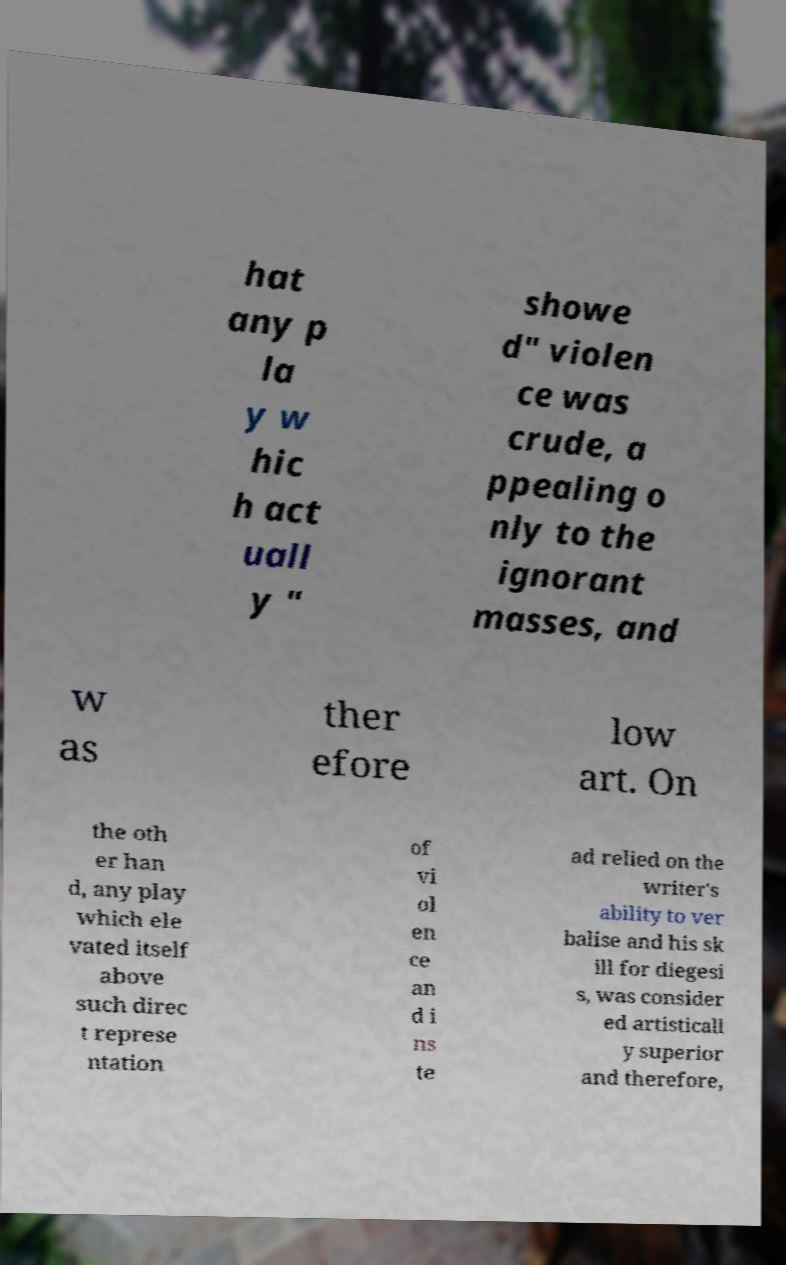Please identify and transcribe the text found in this image. hat any p la y w hic h act uall y " showe d" violen ce was crude, a ppealing o nly to the ignorant masses, and w as ther efore low art. On the oth er han d, any play which ele vated itself above such direc t represe ntation of vi ol en ce an d i ns te ad relied on the writer's ability to ver balise and his sk ill for diegesi s, was consider ed artisticall y superior and therefore, 